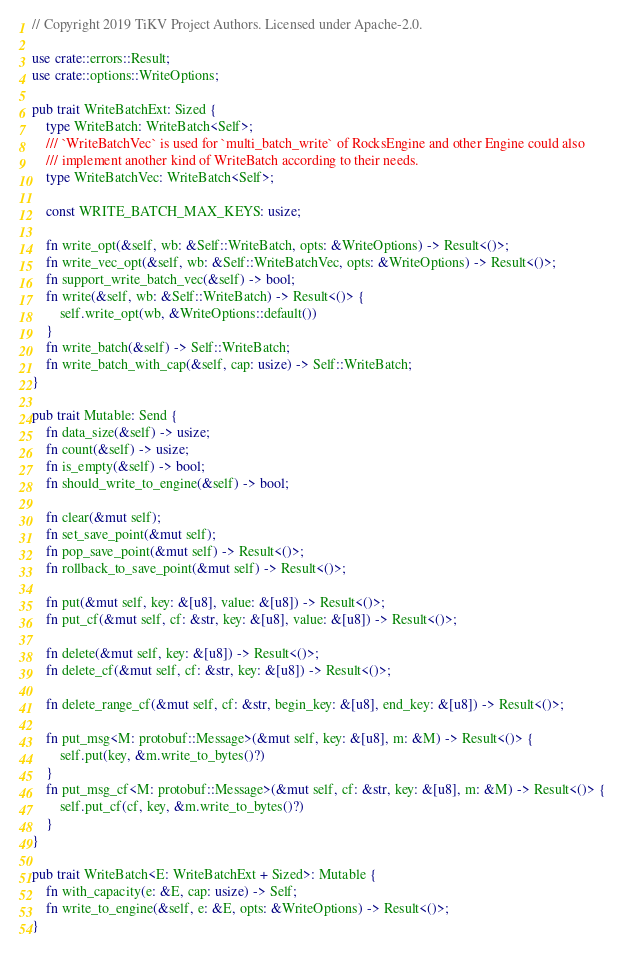Convert code to text. <code><loc_0><loc_0><loc_500><loc_500><_Rust_>// Copyright 2019 TiKV Project Authors. Licensed under Apache-2.0.

use crate::errors::Result;
use crate::options::WriteOptions;

pub trait WriteBatchExt: Sized {
    type WriteBatch: WriteBatch<Self>;
    /// `WriteBatchVec` is used for `multi_batch_write` of RocksEngine and other Engine could also
    /// implement another kind of WriteBatch according to their needs.
    type WriteBatchVec: WriteBatch<Self>;

    const WRITE_BATCH_MAX_KEYS: usize;

    fn write_opt(&self, wb: &Self::WriteBatch, opts: &WriteOptions) -> Result<()>;
    fn write_vec_opt(&self, wb: &Self::WriteBatchVec, opts: &WriteOptions) -> Result<()>;
    fn support_write_batch_vec(&self) -> bool;
    fn write(&self, wb: &Self::WriteBatch) -> Result<()> {
        self.write_opt(wb, &WriteOptions::default())
    }
    fn write_batch(&self) -> Self::WriteBatch;
    fn write_batch_with_cap(&self, cap: usize) -> Self::WriteBatch;
}

pub trait Mutable: Send {
    fn data_size(&self) -> usize;
    fn count(&self) -> usize;
    fn is_empty(&self) -> bool;
    fn should_write_to_engine(&self) -> bool;

    fn clear(&mut self);
    fn set_save_point(&mut self);
    fn pop_save_point(&mut self) -> Result<()>;
    fn rollback_to_save_point(&mut self) -> Result<()>;

    fn put(&mut self, key: &[u8], value: &[u8]) -> Result<()>;
    fn put_cf(&mut self, cf: &str, key: &[u8], value: &[u8]) -> Result<()>;

    fn delete(&mut self, key: &[u8]) -> Result<()>;
    fn delete_cf(&mut self, cf: &str, key: &[u8]) -> Result<()>;

    fn delete_range_cf(&mut self, cf: &str, begin_key: &[u8], end_key: &[u8]) -> Result<()>;

    fn put_msg<M: protobuf::Message>(&mut self, key: &[u8], m: &M) -> Result<()> {
        self.put(key, &m.write_to_bytes()?)
    }
    fn put_msg_cf<M: protobuf::Message>(&mut self, cf: &str, key: &[u8], m: &M) -> Result<()> {
        self.put_cf(cf, key, &m.write_to_bytes()?)
    }
}

pub trait WriteBatch<E: WriteBatchExt + Sized>: Mutable {
    fn with_capacity(e: &E, cap: usize) -> Self;
    fn write_to_engine(&self, e: &E, opts: &WriteOptions) -> Result<()>;
}
</code> 